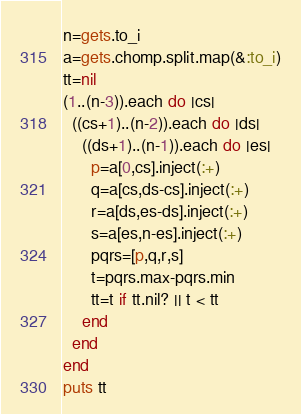<code> <loc_0><loc_0><loc_500><loc_500><_Ruby_>n=gets.to_i
a=gets.chomp.split.map(&:to_i)
tt=nil
(1..(n-3)).each do |cs|
  ((cs+1)..(n-2)).each do |ds|
    ((ds+1)..(n-1)).each do |es|
      p=a[0,cs].inject(:+)
      q=a[cs,ds-cs].inject(:+)
      r=a[ds,es-ds].inject(:+)
      s=a[es,n-es].inject(:+)
      pqrs=[p,q,r,s]
      t=pqrs.max-pqrs.min
      tt=t if tt.nil? || t < tt
    end
  end
end
puts tt
</code> 